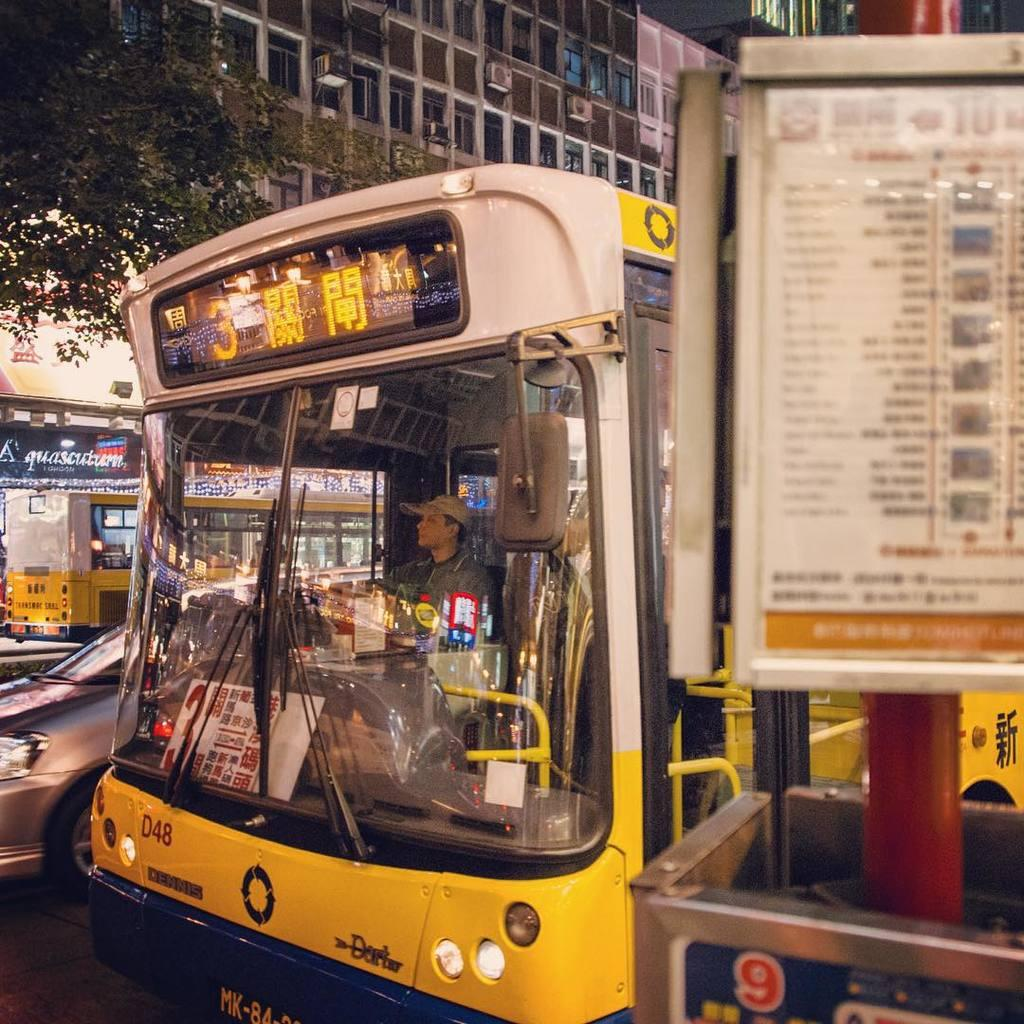<image>
Write a terse but informative summary of the picture. The number 3 bus is labelled as "D48." 